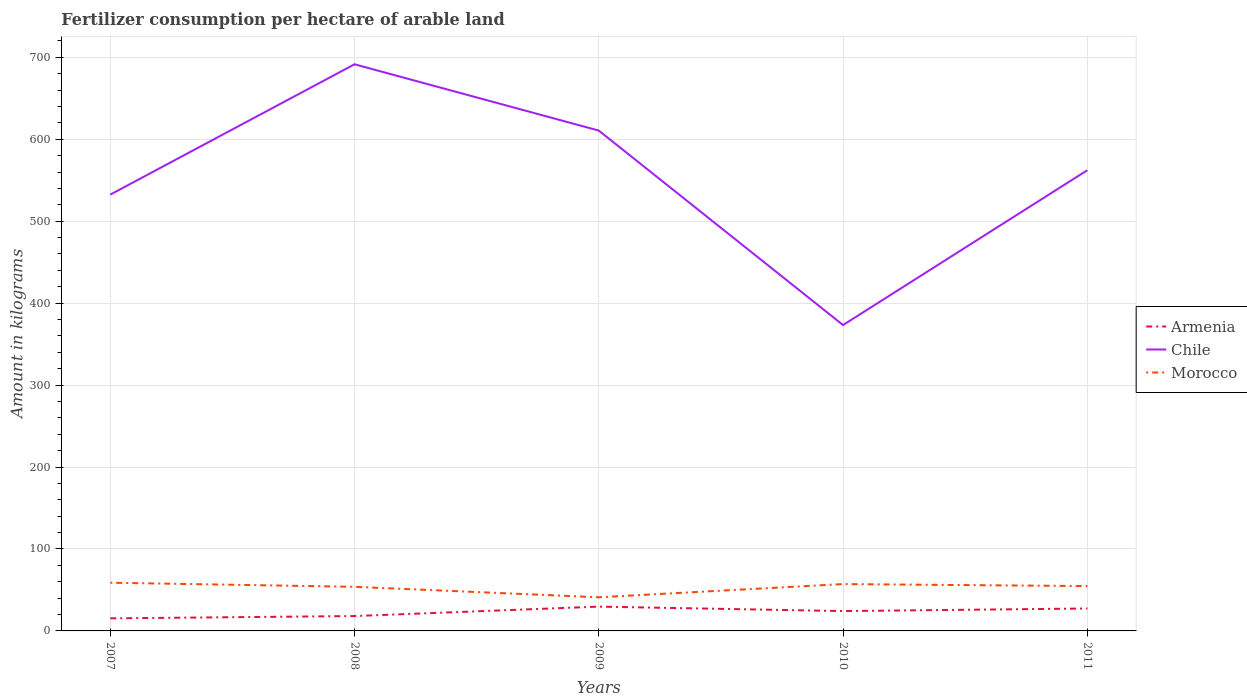How many different coloured lines are there?
Your answer should be very brief. 3. Is the number of lines equal to the number of legend labels?
Offer a very short reply. Yes. Across all years, what is the maximum amount of fertilizer consumption in Armenia?
Provide a succinct answer. 15.33. In which year was the amount of fertilizer consumption in Armenia maximum?
Provide a succinct answer. 2007. What is the total amount of fertilizer consumption in Morocco in the graph?
Ensure brevity in your answer.  12.76. What is the difference between the highest and the second highest amount of fertilizer consumption in Chile?
Your answer should be very brief. 318.21. What is the difference between the highest and the lowest amount of fertilizer consumption in Chile?
Your answer should be very brief. 3. How many lines are there?
Provide a succinct answer. 3. How many years are there in the graph?
Make the answer very short. 5. Does the graph contain grids?
Offer a terse response. Yes. Where does the legend appear in the graph?
Offer a terse response. Center right. How many legend labels are there?
Your answer should be very brief. 3. How are the legend labels stacked?
Give a very brief answer. Vertical. What is the title of the graph?
Keep it short and to the point. Fertilizer consumption per hectare of arable land. What is the label or title of the Y-axis?
Your response must be concise. Amount in kilograms. What is the Amount in kilograms of Armenia in 2007?
Keep it short and to the point. 15.33. What is the Amount in kilograms in Chile in 2007?
Your answer should be compact. 532.41. What is the Amount in kilograms of Morocco in 2007?
Ensure brevity in your answer.  58.83. What is the Amount in kilograms in Armenia in 2008?
Make the answer very short. 18.15. What is the Amount in kilograms in Chile in 2008?
Make the answer very short. 691.46. What is the Amount in kilograms in Morocco in 2008?
Make the answer very short. 53.83. What is the Amount in kilograms in Armenia in 2009?
Your answer should be very brief. 29.67. What is the Amount in kilograms in Chile in 2009?
Offer a terse response. 610.55. What is the Amount in kilograms of Morocco in 2009?
Make the answer very short. 41.07. What is the Amount in kilograms in Armenia in 2010?
Offer a terse response. 24.2. What is the Amount in kilograms in Chile in 2010?
Keep it short and to the point. 373.25. What is the Amount in kilograms of Morocco in 2010?
Your answer should be very brief. 57.17. What is the Amount in kilograms of Armenia in 2011?
Your response must be concise. 27.37. What is the Amount in kilograms of Chile in 2011?
Give a very brief answer. 562.19. What is the Amount in kilograms of Morocco in 2011?
Keep it short and to the point. 54.7. Across all years, what is the maximum Amount in kilograms in Armenia?
Your answer should be compact. 29.67. Across all years, what is the maximum Amount in kilograms of Chile?
Ensure brevity in your answer.  691.46. Across all years, what is the maximum Amount in kilograms in Morocco?
Give a very brief answer. 58.83. Across all years, what is the minimum Amount in kilograms in Armenia?
Provide a short and direct response. 15.33. Across all years, what is the minimum Amount in kilograms in Chile?
Keep it short and to the point. 373.25. Across all years, what is the minimum Amount in kilograms of Morocco?
Provide a succinct answer. 41.07. What is the total Amount in kilograms of Armenia in the graph?
Ensure brevity in your answer.  114.72. What is the total Amount in kilograms of Chile in the graph?
Make the answer very short. 2769.86. What is the total Amount in kilograms of Morocco in the graph?
Offer a terse response. 265.59. What is the difference between the Amount in kilograms of Armenia in 2007 and that in 2008?
Keep it short and to the point. -2.82. What is the difference between the Amount in kilograms of Chile in 2007 and that in 2008?
Give a very brief answer. -159.04. What is the difference between the Amount in kilograms of Morocco in 2007 and that in 2008?
Your response must be concise. 5. What is the difference between the Amount in kilograms of Armenia in 2007 and that in 2009?
Give a very brief answer. -14.33. What is the difference between the Amount in kilograms of Chile in 2007 and that in 2009?
Keep it short and to the point. -78.14. What is the difference between the Amount in kilograms of Morocco in 2007 and that in 2009?
Ensure brevity in your answer.  17.76. What is the difference between the Amount in kilograms of Armenia in 2007 and that in 2010?
Your response must be concise. -8.87. What is the difference between the Amount in kilograms of Chile in 2007 and that in 2010?
Your response must be concise. 159.16. What is the difference between the Amount in kilograms of Morocco in 2007 and that in 2010?
Provide a succinct answer. 1.66. What is the difference between the Amount in kilograms of Armenia in 2007 and that in 2011?
Your answer should be very brief. -12.04. What is the difference between the Amount in kilograms in Chile in 2007 and that in 2011?
Keep it short and to the point. -29.78. What is the difference between the Amount in kilograms of Morocco in 2007 and that in 2011?
Offer a very short reply. 4.13. What is the difference between the Amount in kilograms of Armenia in 2008 and that in 2009?
Your response must be concise. -11.52. What is the difference between the Amount in kilograms in Chile in 2008 and that in 2009?
Ensure brevity in your answer.  80.9. What is the difference between the Amount in kilograms in Morocco in 2008 and that in 2009?
Your answer should be very brief. 12.76. What is the difference between the Amount in kilograms in Armenia in 2008 and that in 2010?
Your response must be concise. -6.05. What is the difference between the Amount in kilograms in Chile in 2008 and that in 2010?
Your answer should be compact. 318.21. What is the difference between the Amount in kilograms of Morocco in 2008 and that in 2010?
Make the answer very short. -3.34. What is the difference between the Amount in kilograms in Armenia in 2008 and that in 2011?
Your answer should be very brief. -9.22. What is the difference between the Amount in kilograms in Chile in 2008 and that in 2011?
Make the answer very short. 129.27. What is the difference between the Amount in kilograms of Morocco in 2008 and that in 2011?
Give a very brief answer. -0.87. What is the difference between the Amount in kilograms in Armenia in 2009 and that in 2010?
Provide a short and direct response. 5.46. What is the difference between the Amount in kilograms in Chile in 2009 and that in 2010?
Provide a succinct answer. 237.3. What is the difference between the Amount in kilograms of Morocco in 2009 and that in 2010?
Make the answer very short. -16.11. What is the difference between the Amount in kilograms of Armenia in 2009 and that in 2011?
Offer a terse response. 2.3. What is the difference between the Amount in kilograms of Chile in 2009 and that in 2011?
Keep it short and to the point. 48.36. What is the difference between the Amount in kilograms in Morocco in 2009 and that in 2011?
Ensure brevity in your answer.  -13.63. What is the difference between the Amount in kilograms of Armenia in 2010 and that in 2011?
Offer a terse response. -3.17. What is the difference between the Amount in kilograms in Chile in 2010 and that in 2011?
Your response must be concise. -188.94. What is the difference between the Amount in kilograms of Morocco in 2010 and that in 2011?
Keep it short and to the point. 2.47. What is the difference between the Amount in kilograms of Armenia in 2007 and the Amount in kilograms of Chile in 2008?
Make the answer very short. -676.12. What is the difference between the Amount in kilograms of Armenia in 2007 and the Amount in kilograms of Morocco in 2008?
Give a very brief answer. -38.49. What is the difference between the Amount in kilograms of Chile in 2007 and the Amount in kilograms of Morocco in 2008?
Provide a short and direct response. 478.59. What is the difference between the Amount in kilograms of Armenia in 2007 and the Amount in kilograms of Chile in 2009?
Ensure brevity in your answer.  -595.22. What is the difference between the Amount in kilograms of Armenia in 2007 and the Amount in kilograms of Morocco in 2009?
Make the answer very short. -25.73. What is the difference between the Amount in kilograms of Chile in 2007 and the Amount in kilograms of Morocco in 2009?
Ensure brevity in your answer.  491.35. What is the difference between the Amount in kilograms in Armenia in 2007 and the Amount in kilograms in Chile in 2010?
Provide a short and direct response. -357.92. What is the difference between the Amount in kilograms in Armenia in 2007 and the Amount in kilograms in Morocco in 2010?
Ensure brevity in your answer.  -41.84. What is the difference between the Amount in kilograms in Chile in 2007 and the Amount in kilograms in Morocco in 2010?
Provide a short and direct response. 475.24. What is the difference between the Amount in kilograms in Armenia in 2007 and the Amount in kilograms in Chile in 2011?
Provide a succinct answer. -546.86. What is the difference between the Amount in kilograms of Armenia in 2007 and the Amount in kilograms of Morocco in 2011?
Make the answer very short. -39.37. What is the difference between the Amount in kilograms of Chile in 2007 and the Amount in kilograms of Morocco in 2011?
Make the answer very short. 477.71. What is the difference between the Amount in kilograms in Armenia in 2008 and the Amount in kilograms in Chile in 2009?
Make the answer very short. -592.4. What is the difference between the Amount in kilograms of Armenia in 2008 and the Amount in kilograms of Morocco in 2009?
Provide a short and direct response. -22.91. What is the difference between the Amount in kilograms of Chile in 2008 and the Amount in kilograms of Morocco in 2009?
Your answer should be very brief. 650.39. What is the difference between the Amount in kilograms of Armenia in 2008 and the Amount in kilograms of Chile in 2010?
Provide a succinct answer. -355.1. What is the difference between the Amount in kilograms in Armenia in 2008 and the Amount in kilograms in Morocco in 2010?
Offer a terse response. -39.02. What is the difference between the Amount in kilograms of Chile in 2008 and the Amount in kilograms of Morocco in 2010?
Provide a short and direct response. 634.29. What is the difference between the Amount in kilograms in Armenia in 2008 and the Amount in kilograms in Chile in 2011?
Ensure brevity in your answer.  -544.04. What is the difference between the Amount in kilograms of Armenia in 2008 and the Amount in kilograms of Morocco in 2011?
Ensure brevity in your answer.  -36.55. What is the difference between the Amount in kilograms in Chile in 2008 and the Amount in kilograms in Morocco in 2011?
Give a very brief answer. 636.76. What is the difference between the Amount in kilograms in Armenia in 2009 and the Amount in kilograms in Chile in 2010?
Provide a short and direct response. -343.58. What is the difference between the Amount in kilograms of Armenia in 2009 and the Amount in kilograms of Morocco in 2010?
Make the answer very short. -27.5. What is the difference between the Amount in kilograms of Chile in 2009 and the Amount in kilograms of Morocco in 2010?
Provide a succinct answer. 553.38. What is the difference between the Amount in kilograms of Armenia in 2009 and the Amount in kilograms of Chile in 2011?
Ensure brevity in your answer.  -532.52. What is the difference between the Amount in kilograms of Armenia in 2009 and the Amount in kilograms of Morocco in 2011?
Your response must be concise. -25.03. What is the difference between the Amount in kilograms of Chile in 2009 and the Amount in kilograms of Morocco in 2011?
Your response must be concise. 555.85. What is the difference between the Amount in kilograms of Armenia in 2010 and the Amount in kilograms of Chile in 2011?
Provide a succinct answer. -537.99. What is the difference between the Amount in kilograms of Armenia in 2010 and the Amount in kilograms of Morocco in 2011?
Your answer should be compact. -30.5. What is the difference between the Amount in kilograms of Chile in 2010 and the Amount in kilograms of Morocco in 2011?
Your answer should be very brief. 318.55. What is the average Amount in kilograms of Armenia per year?
Offer a very short reply. 22.94. What is the average Amount in kilograms in Chile per year?
Your answer should be compact. 553.97. What is the average Amount in kilograms in Morocco per year?
Provide a succinct answer. 53.12. In the year 2007, what is the difference between the Amount in kilograms in Armenia and Amount in kilograms in Chile?
Provide a short and direct response. -517.08. In the year 2007, what is the difference between the Amount in kilograms of Armenia and Amount in kilograms of Morocco?
Provide a short and direct response. -43.5. In the year 2007, what is the difference between the Amount in kilograms in Chile and Amount in kilograms in Morocco?
Give a very brief answer. 473.58. In the year 2008, what is the difference between the Amount in kilograms in Armenia and Amount in kilograms in Chile?
Keep it short and to the point. -673.31. In the year 2008, what is the difference between the Amount in kilograms in Armenia and Amount in kilograms in Morocco?
Make the answer very short. -35.68. In the year 2008, what is the difference between the Amount in kilograms in Chile and Amount in kilograms in Morocco?
Keep it short and to the point. 637.63. In the year 2009, what is the difference between the Amount in kilograms in Armenia and Amount in kilograms in Chile?
Your answer should be compact. -580.89. In the year 2009, what is the difference between the Amount in kilograms in Armenia and Amount in kilograms in Morocco?
Give a very brief answer. -11.4. In the year 2009, what is the difference between the Amount in kilograms in Chile and Amount in kilograms in Morocco?
Provide a succinct answer. 569.49. In the year 2010, what is the difference between the Amount in kilograms in Armenia and Amount in kilograms in Chile?
Offer a terse response. -349.05. In the year 2010, what is the difference between the Amount in kilograms of Armenia and Amount in kilograms of Morocco?
Your response must be concise. -32.97. In the year 2010, what is the difference between the Amount in kilograms in Chile and Amount in kilograms in Morocco?
Ensure brevity in your answer.  316.08. In the year 2011, what is the difference between the Amount in kilograms of Armenia and Amount in kilograms of Chile?
Ensure brevity in your answer.  -534.82. In the year 2011, what is the difference between the Amount in kilograms in Armenia and Amount in kilograms in Morocco?
Your response must be concise. -27.33. In the year 2011, what is the difference between the Amount in kilograms of Chile and Amount in kilograms of Morocco?
Make the answer very short. 507.49. What is the ratio of the Amount in kilograms in Armenia in 2007 to that in 2008?
Keep it short and to the point. 0.84. What is the ratio of the Amount in kilograms of Chile in 2007 to that in 2008?
Provide a succinct answer. 0.77. What is the ratio of the Amount in kilograms in Morocco in 2007 to that in 2008?
Make the answer very short. 1.09. What is the ratio of the Amount in kilograms of Armenia in 2007 to that in 2009?
Ensure brevity in your answer.  0.52. What is the ratio of the Amount in kilograms of Chile in 2007 to that in 2009?
Your answer should be very brief. 0.87. What is the ratio of the Amount in kilograms of Morocco in 2007 to that in 2009?
Ensure brevity in your answer.  1.43. What is the ratio of the Amount in kilograms of Armenia in 2007 to that in 2010?
Give a very brief answer. 0.63. What is the ratio of the Amount in kilograms in Chile in 2007 to that in 2010?
Ensure brevity in your answer.  1.43. What is the ratio of the Amount in kilograms of Armenia in 2007 to that in 2011?
Offer a terse response. 0.56. What is the ratio of the Amount in kilograms of Chile in 2007 to that in 2011?
Ensure brevity in your answer.  0.95. What is the ratio of the Amount in kilograms in Morocco in 2007 to that in 2011?
Provide a succinct answer. 1.08. What is the ratio of the Amount in kilograms of Armenia in 2008 to that in 2009?
Your response must be concise. 0.61. What is the ratio of the Amount in kilograms in Chile in 2008 to that in 2009?
Ensure brevity in your answer.  1.13. What is the ratio of the Amount in kilograms of Morocco in 2008 to that in 2009?
Ensure brevity in your answer.  1.31. What is the ratio of the Amount in kilograms in Armenia in 2008 to that in 2010?
Offer a very short reply. 0.75. What is the ratio of the Amount in kilograms of Chile in 2008 to that in 2010?
Your response must be concise. 1.85. What is the ratio of the Amount in kilograms of Morocco in 2008 to that in 2010?
Provide a succinct answer. 0.94. What is the ratio of the Amount in kilograms of Armenia in 2008 to that in 2011?
Ensure brevity in your answer.  0.66. What is the ratio of the Amount in kilograms in Chile in 2008 to that in 2011?
Make the answer very short. 1.23. What is the ratio of the Amount in kilograms of Armenia in 2009 to that in 2010?
Ensure brevity in your answer.  1.23. What is the ratio of the Amount in kilograms of Chile in 2009 to that in 2010?
Your response must be concise. 1.64. What is the ratio of the Amount in kilograms in Morocco in 2009 to that in 2010?
Offer a very short reply. 0.72. What is the ratio of the Amount in kilograms of Armenia in 2009 to that in 2011?
Provide a short and direct response. 1.08. What is the ratio of the Amount in kilograms in Chile in 2009 to that in 2011?
Offer a very short reply. 1.09. What is the ratio of the Amount in kilograms in Morocco in 2009 to that in 2011?
Your response must be concise. 0.75. What is the ratio of the Amount in kilograms of Armenia in 2010 to that in 2011?
Your answer should be compact. 0.88. What is the ratio of the Amount in kilograms in Chile in 2010 to that in 2011?
Provide a succinct answer. 0.66. What is the ratio of the Amount in kilograms of Morocco in 2010 to that in 2011?
Your answer should be very brief. 1.05. What is the difference between the highest and the second highest Amount in kilograms of Armenia?
Keep it short and to the point. 2.3. What is the difference between the highest and the second highest Amount in kilograms of Chile?
Make the answer very short. 80.9. What is the difference between the highest and the second highest Amount in kilograms of Morocco?
Your answer should be compact. 1.66. What is the difference between the highest and the lowest Amount in kilograms of Armenia?
Your response must be concise. 14.33. What is the difference between the highest and the lowest Amount in kilograms in Chile?
Your response must be concise. 318.21. What is the difference between the highest and the lowest Amount in kilograms of Morocco?
Your response must be concise. 17.76. 